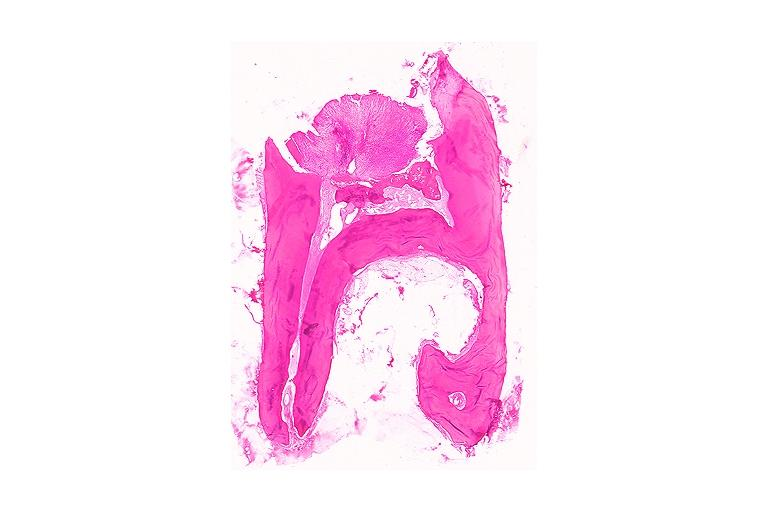what does this image show?
Answer the question using a single word or phrase. Chronic hyperplastic pulpitis 